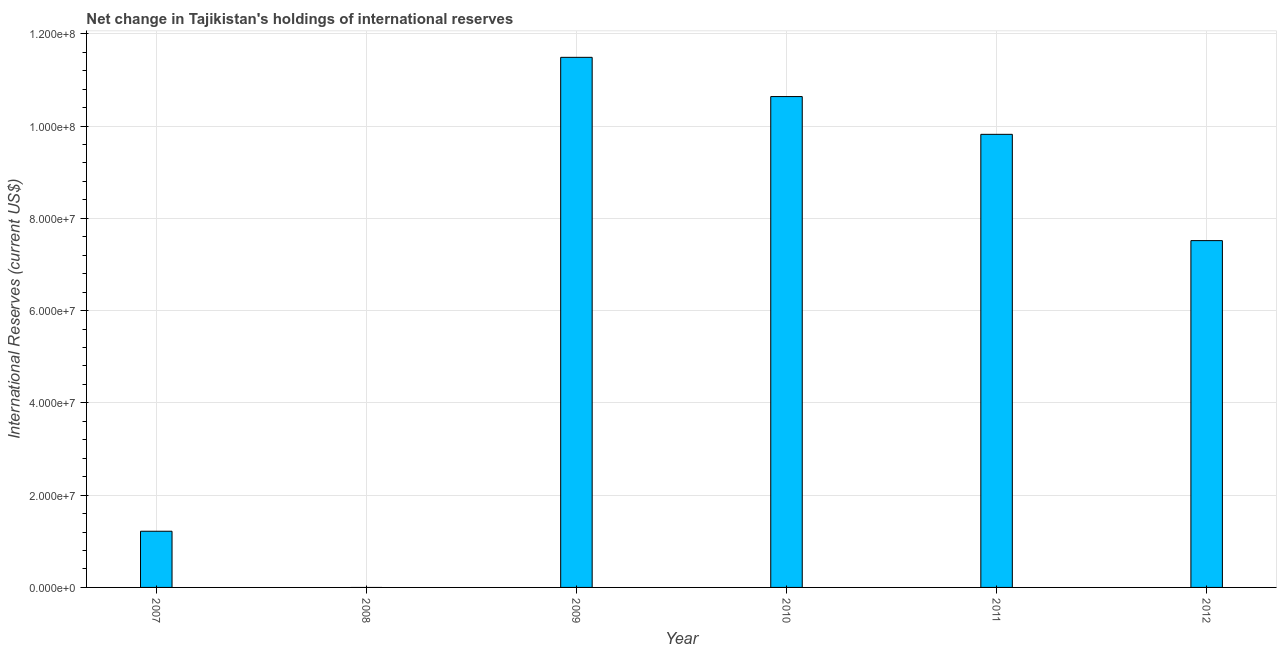Does the graph contain any zero values?
Keep it short and to the point. Yes. What is the title of the graph?
Your answer should be compact. Net change in Tajikistan's holdings of international reserves. What is the label or title of the Y-axis?
Provide a succinct answer. International Reserves (current US$). What is the reserves and related items in 2009?
Provide a succinct answer. 1.15e+08. Across all years, what is the maximum reserves and related items?
Make the answer very short. 1.15e+08. In which year was the reserves and related items maximum?
Your answer should be compact. 2009. What is the sum of the reserves and related items?
Provide a short and direct response. 4.07e+08. What is the difference between the reserves and related items in 2007 and 2011?
Your answer should be compact. -8.60e+07. What is the average reserves and related items per year?
Your answer should be compact. 6.78e+07. What is the median reserves and related items?
Make the answer very short. 8.67e+07. In how many years, is the reserves and related items greater than 4000000 US$?
Your answer should be compact. 5. What is the ratio of the reserves and related items in 2009 to that in 2012?
Ensure brevity in your answer.  1.53. Is the reserves and related items in 2007 less than that in 2011?
Ensure brevity in your answer.  Yes. What is the difference between the highest and the second highest reserves and related items?
Keep it short and to the point. 8.50e+06. Is the sum of the reserves and related items in 2011 and 2012 greater than the maximum reserves and related items across all years?
Provide a succinct answer. Yes. What is the difference between the highest and the lowest reserves and related items?
Your answer should be very brief. 1.15e+08. How many bars are there?
Provide a short and direct response. 5. What is the International Reserves (current US$) in 2007?
Offer a very short reply. 1.22e+07. What is the International Reserves (current US$) of 2008?
Offer a terse response. 0. What is the International Reserves (current US$) of 2009?
Provide a short and direct response. 1.15e+08. What is the International Reserves (current US$) in 2010?
Provide a succinct answer. 1.06e+08. What is the International Reserves (current US$) of 2011?
Provide a short and direct response. 9.82e+07. What is the International Reserves (current US$) in 2012?
Your answer should be very brief. 7.52e+07. What is the difference between the International Reserves (current US$) in 2007 and 2009?
Give a very brief answer. -1.03e+08. What is the difference between the International Reserves (current US$) in 2007 and 2010?
Offer a very short reply. -9.42e+07. What is the difference between the International Reserves (current US$) in 2007 and 2011?
Give a very brief answer. -8.60e+07. What is the difference between the International Reserves (current US$) in 2007 and 2012?
Provide a short and direct response. -6.30e+07. What is the difference between the International Reserves (current US$) in 2009 and 2010?
Offer a very short reply. 8.50e+06. What is the difference between the International Reserves (current US$) in 2009 and 2011?
Your answer should be compact. 1.67e+07. What is the difference between the International Reserves (current US$) in 2009 and 2012?
Offer a very short reply. 3.97e+07. What is the difference between the International Reserves (current US$) in 2010 and 2011?
Give a very brief answer. 8.18e+06. What is the difference between the International Reserves (current US$) in 2010 and 2012?
Your response must be concise. 3.12e+07. What is the difference between the International Reserves (current US$) in 2011 and 2012?
Your answer should be very brief. 2.30e+07. What is the ratio of the International Reserves (current US$) in 2007 to that in 2009?
Offer a terse response. 0.11. What is the ratio of the International Reserves (current US$) in 2007 to that in 2010?
Offer a very short reply. 0.11. What is the ratio of the International Reserves (current US$) in 2007 to that in 2011?
Keep it short and to the point. 0.12. What is the ratio of the International Reserves (current US$) in 2007 to that in 2012?
Your answer should be very brief. 0.16. What is the ratio of the International Reserves (current US$) in 2009 to that in 2011?
Offer a terse response. 1.17. What is the ratio of the International Reserves (current US$) in 2009 to that in 2012?
Make the answer very short. 1.53. What is the ratio of the International Reserves (current US$) in 2010 to that in 2011?
Provide a succinct answer. 1.08. What is the ratio of the International Reserves (current US$) in 2010 to that in 2012?
Your answer should be compact. 1.42. What is the ratio of the International Reserves (current US$) in 2011 to that in 2012?
Provide a succinct answer. 1.31. 